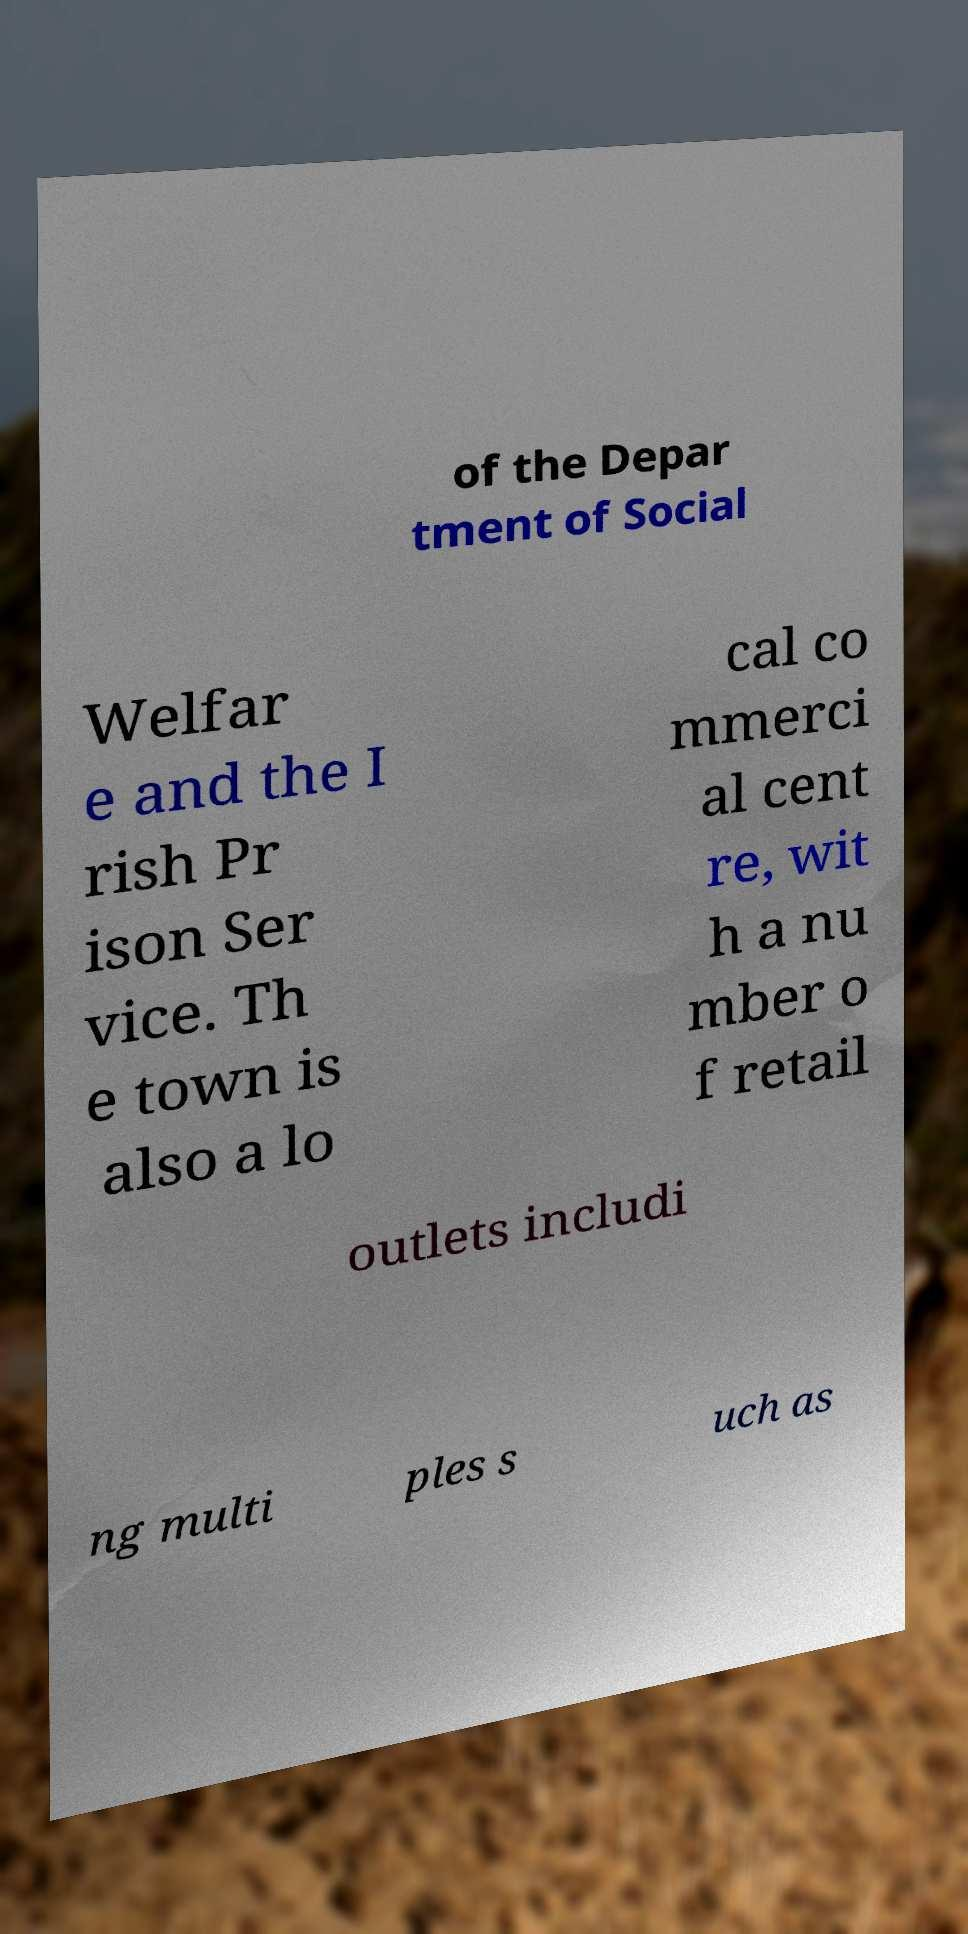Please read and relay the text visible in this image. What does it say? of the Depar tment of Social Welfar e and the I rish Pr ison Ser vice. Th e town is also a lo cal co mmerci al cent re, wit h a nu mber o f retail outlets includi ng multi ples s uch as 